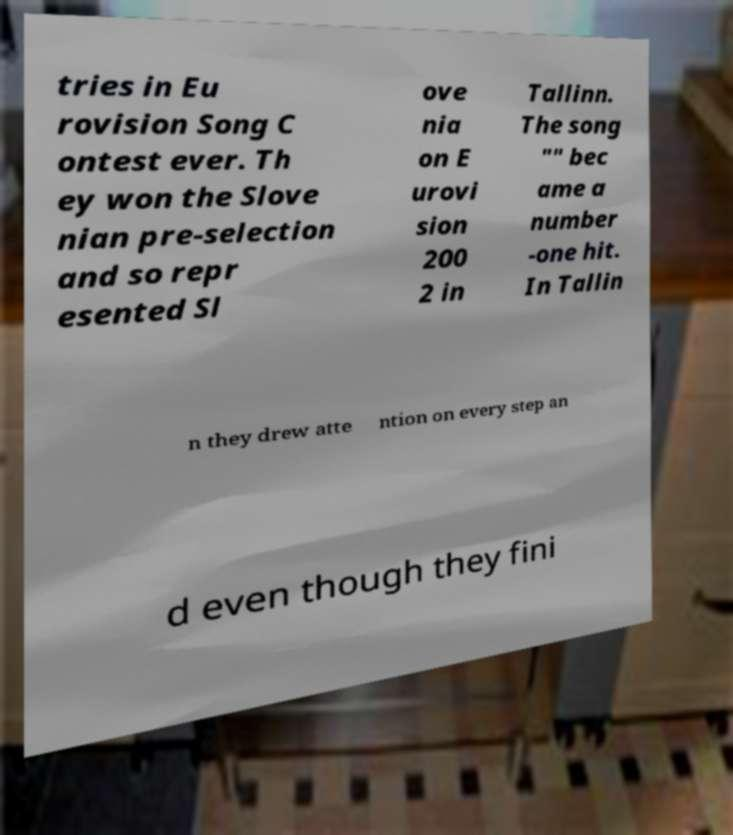Could you assist in decoding the text presented in this image and type it out clearly? tries in Eu rovision Song C ontest ever. Th ey won the Slove nian pre-selection and so repr esented Sl ove nia on E urovi sion 200 2 in Tallinn. The song "" bec ame a number -one hit. In Tallin n they drew atte ntion on every step an d even though they fini 